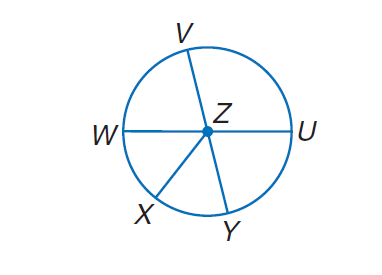Answer the mathemtical geometry problem and directly provide the correct option letter.
Question: In \odot Z, \angle W Z X \cong \angle X Z Y, m \angle V Z U = 4 x, m \angle U Z Y = 2 x + 24, and V Y and W U are diameters. Find m \widehat U Y.
Choices: A: 14 B: 24 C: 76 D: 104 C 